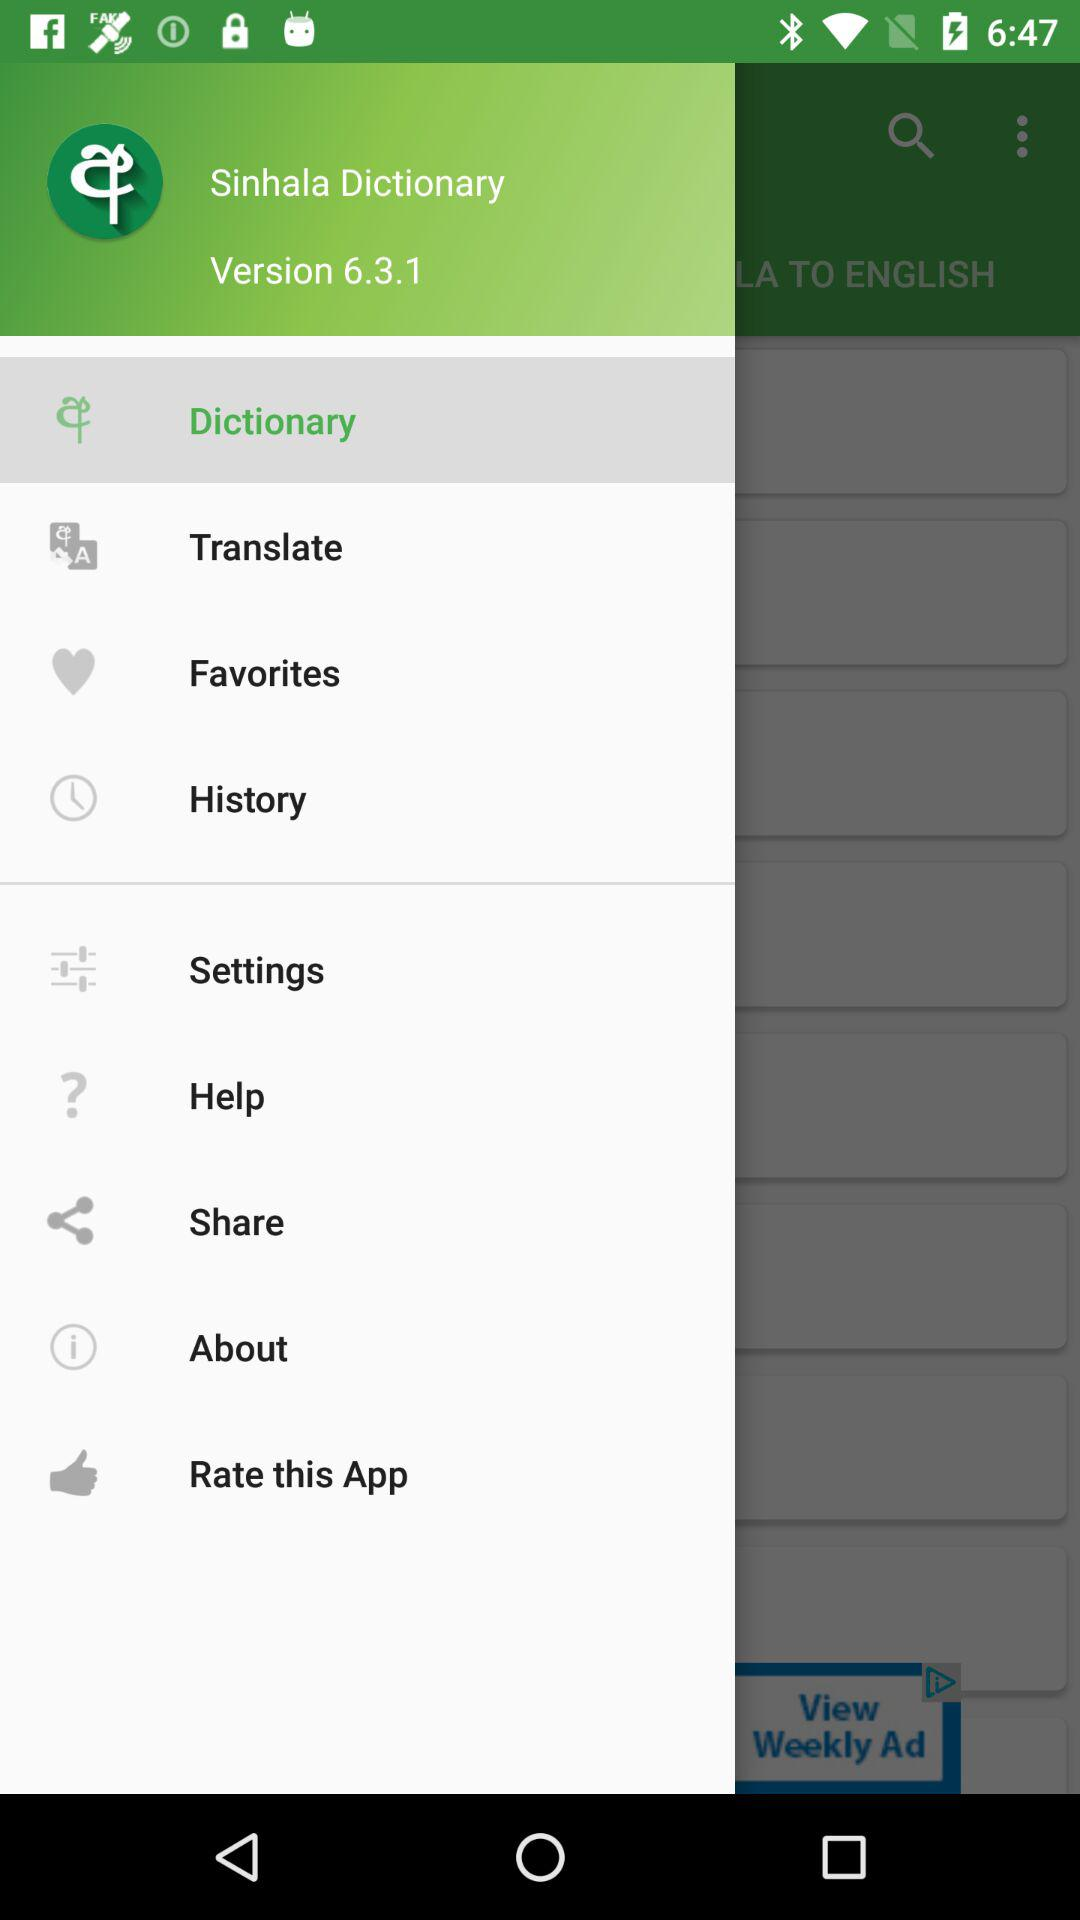What is the application name? The application name is "Sinhala Dictionary". 